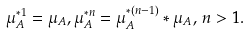Convert formula to latex. <formula><loc_0><loc_0><loc_500><loc_500>\mu _ { A } ^ { * 1 } = \mu _ { A } , \mu _ { A } ^ { * n } = \mu _ { A } ^ { * ( n - 1 ) } * \mu _ { A } , \, n > 1 .</formula> 